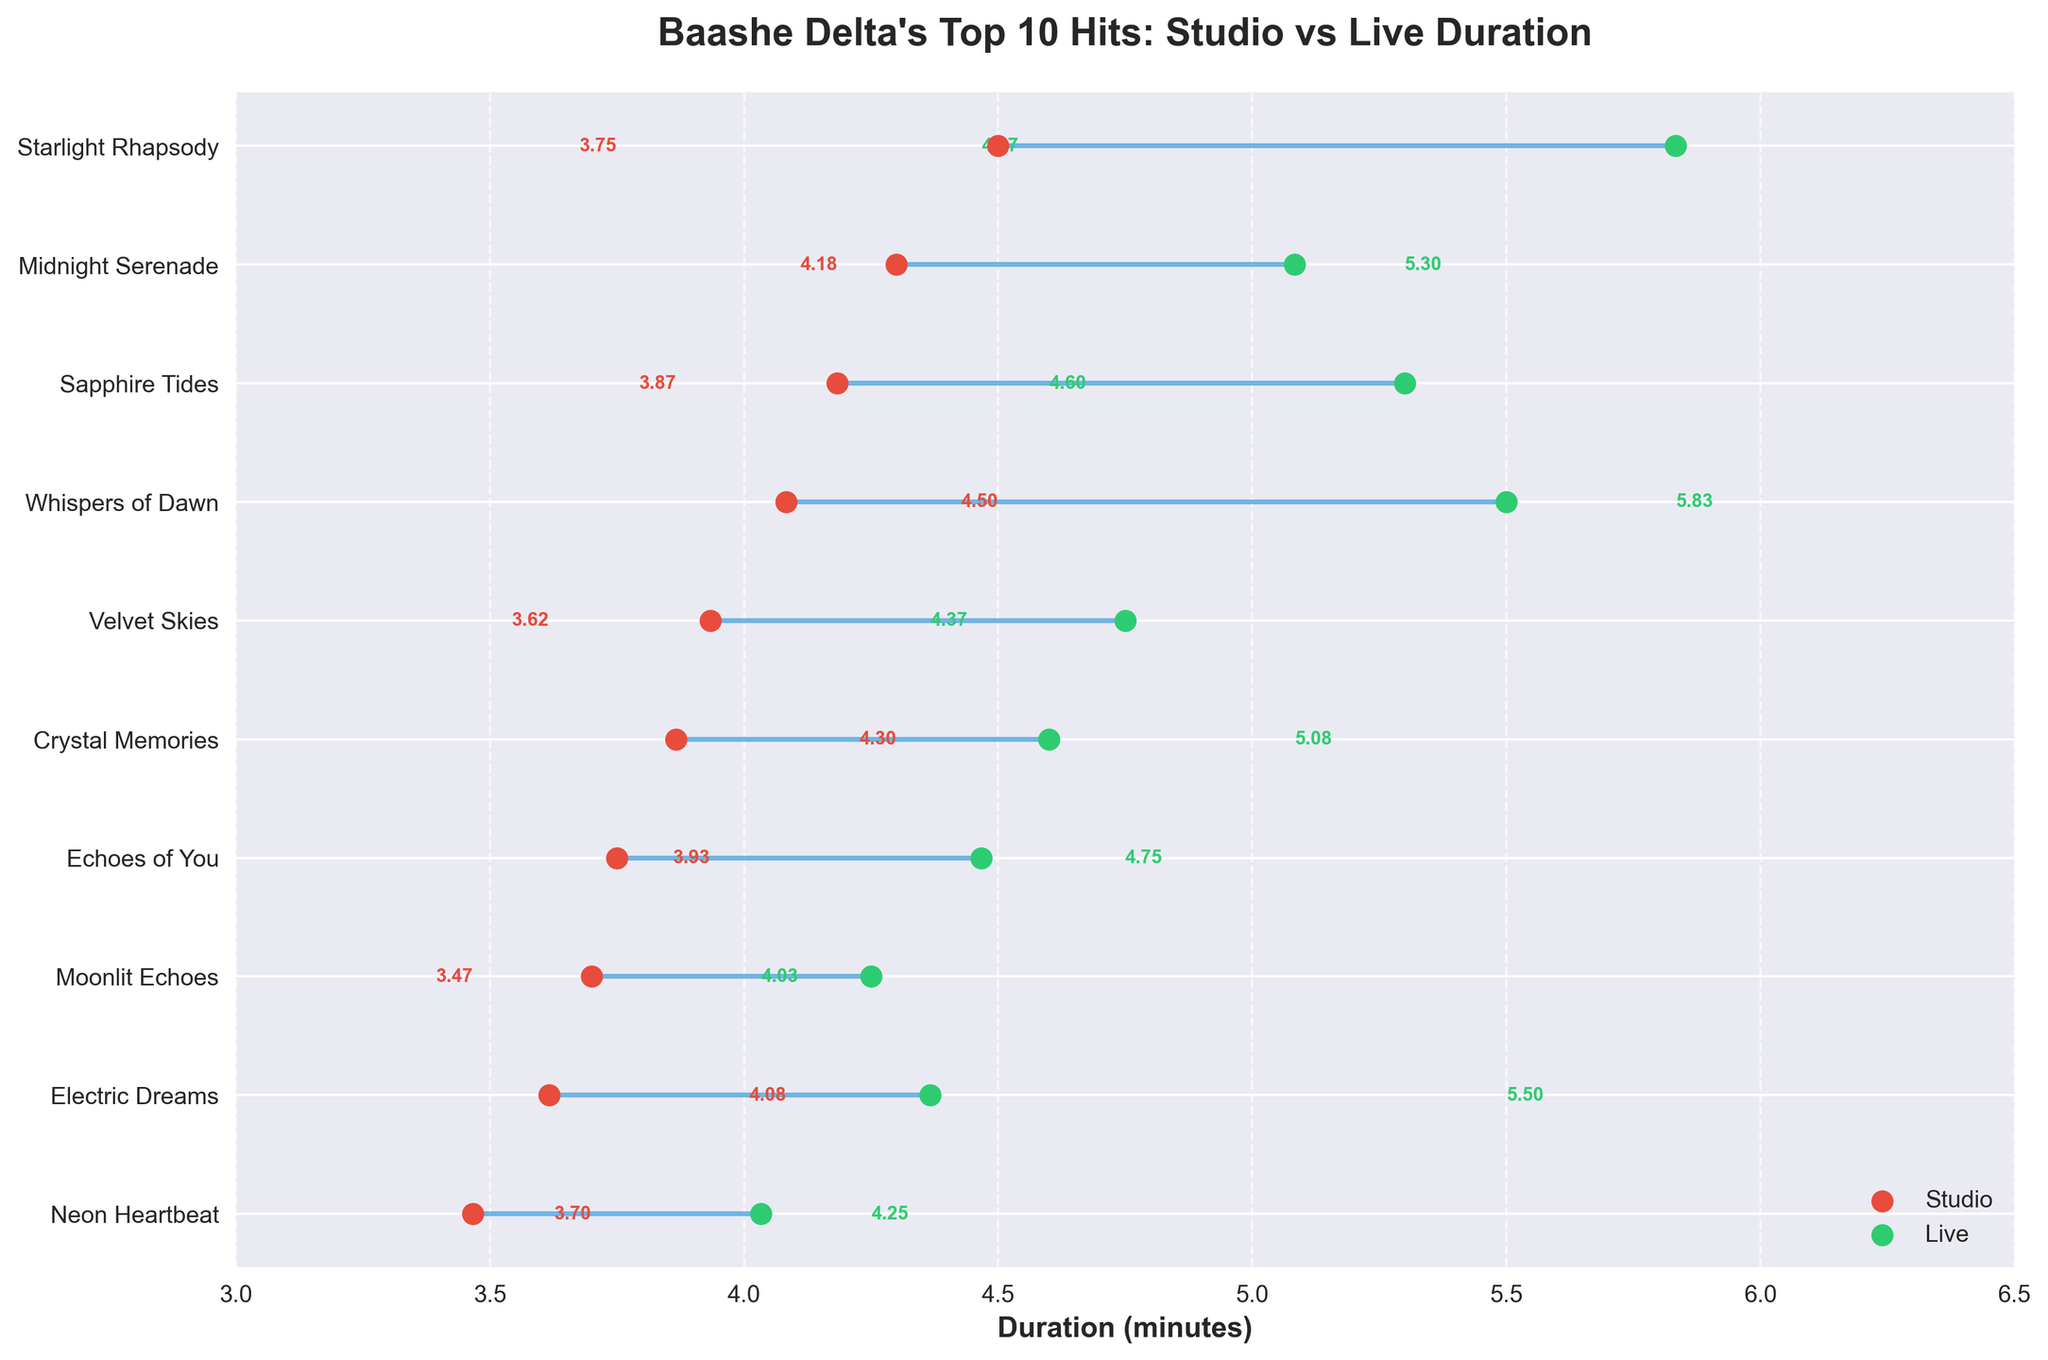What's the title of the plot? The title is usually located at the top of the plot in a bold and larger font. The title here is "Baashe Delta's Top 10 Hits: Studio vs Live Duration" as it is bold and positioned at the top.
Answer: Baashe Delta's Top 10 Hits: Studio vs Live Duration What is the range of the x-axis on the plot? The x-axis range is described by the minimum and maximum values shown on the plot. Here, it ranges from 3 to 6.5 as indicated by the limits displayed on the x-axis.
Answer: 3 to 6.5 Which song has the longest live performance duration? Look for the green dot located furthest to the right on the x-axis, which represents the longest live performance duration. "Starlight Rhapsody" has the green dot furthest to the right at approximately 5.83 minutes.
Answer: Starlight Rhapsody What color represents the live performance duration in the plot? The live performance duration is denoted by one of the two point colors in the plot. Based on the legend, green (color of the scatter points) indicates live performance.
Answer: Green Which song has the shortest studio duration? Locate the red dots (representing studio duration) and identify the one closest to the left x-axis edge. "Neon Heartbeat" has the shortest studio duration.
Answer: Neon Heartbeat How much longer is "Midnight Serenade's" live performance compared to its studio version? Find "Midnight Serenade" on the y-axis and measure the horizontal distance between the red and green dots for this song. The studio duration is about 4.30 minutes, and the live duration is about 5.08 minutes. Subtracting the two values (5.08 - 4.30) gives 0.78 minutes.
Answer: 0.78 minutes Which song shows the smallest difference in duration between its studio version and live performance? Identify the shortest horizontal line connecting the red and green dots between the studio and live durations on the plot. "Neon Heartbeat" has the smallest visual difference.
Answer: Neon Heartbeat What is the average studio duration of all the songs? Calculate the mean duration by adding up all studio durations and dividing by the number of songs. (3.42 + 4.05 + 3.28 + 3.56 + 4.18 + 3.37 + 4.30 + 3.52 + 4.11 + 3.45) / 10 = 37.24 / 10 = 3.72 minutes.
Answer: 3.72 minutes Which song increased the most in duration from studio to live version? Look for the song with the longest horizontal line (largest distance between red and green dots) representing the greatest difference between studio and live durations. "Whispers of Dawn" shows the largest increase from approximately 4.08 to 5.50 minutes.
Answer: Whispers of Dawn 